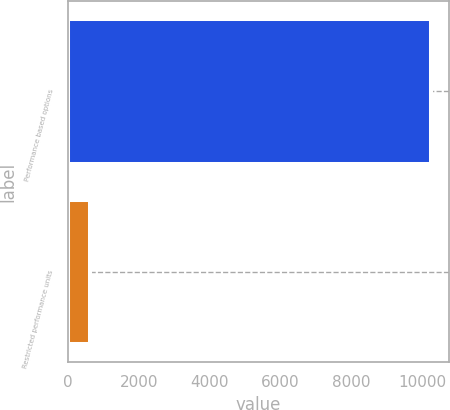Convert chart. <chart><loc_0><loc_0><loc_500><loc_500><bar_chart><fcel>Performance based options<fcel>Restricted performance units<nl><fcel>10253<fcel>633<nl></chart> 